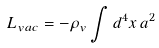<formula> <loc_0><loc_0><loc_500><loc_500>L _ { v a c } = - \rho _ { v } \int { d ^ { 4 } x \, a ^ { 2 } }</formula> 